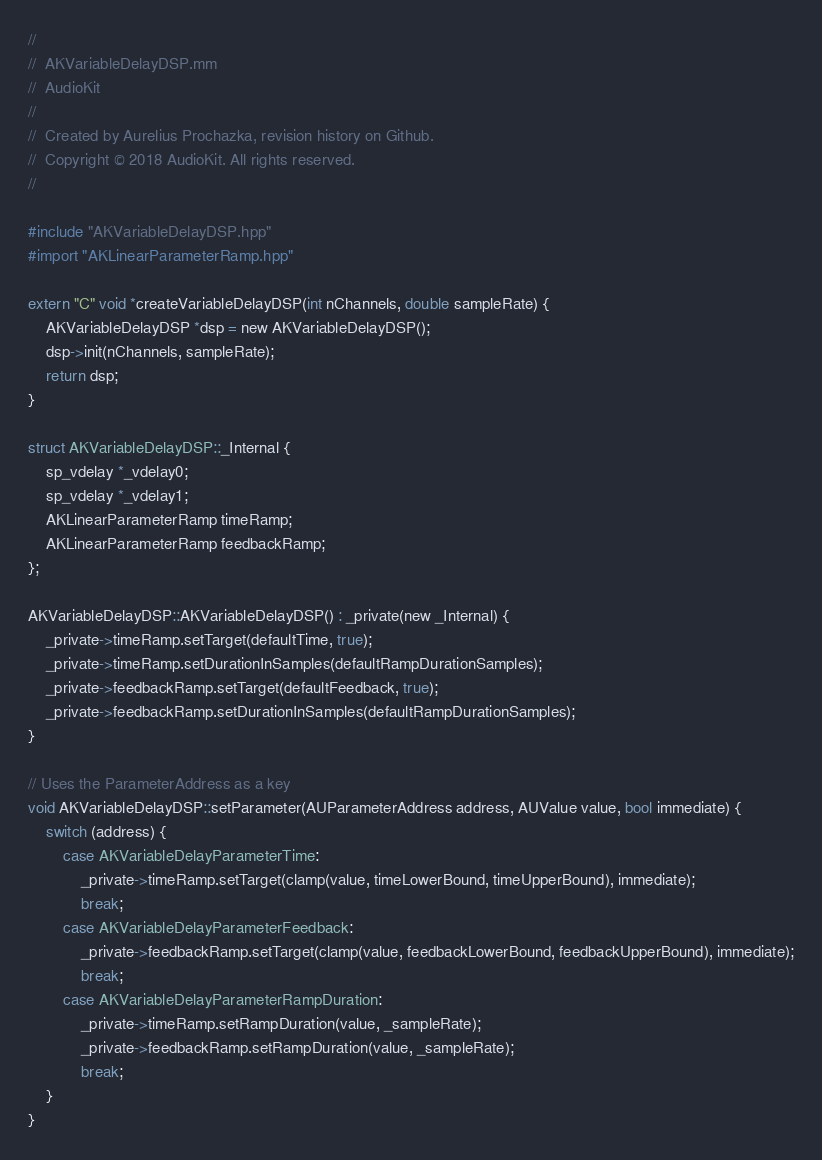Convert code to text. <code><loc_0><loc_0><loc_500><loc_500><_ObjectiveC_>//
//  AKVariableDelayDSP.mm
//  AudioKit
//
//  Created by Aurelius Prochazka, revision history on Github.
//  Copyright © 2018 AudioKit. All rights reserved.
//

#include "AKVariableDelayDSP.hpp"
#import "AKLinearParameterRamp.hpp"

extern "C" void *createVariableDelayDSP(int nChannels, double sampleRate) {
    AKVariableDelayDSP *dsp = new AKVariableDelayDSP();
    dsp->init(nChannels, sampleRate);
    return dsp;
}

struct AKVariableDelayDSP::_Internal {
    sp_vdelay *_vdelay0;
    sp_vdelay *_vdelay1;
    AKLinearParameterRamp timeRamp;
    AKLinearParameterRamp feedbackRamp;
};

AKVariableDelayDSP::AKVariableDelayDSP() : _private(new _Internal) {
    _private->timeRamp.setTarget(defaultTime, true);
    _private->timeRamp.setDurationInSamples(defaultRampDurationSamples);
    _private->feedbackRamp.setTarget(defaultFeedback, true);
    _private->feedbackRamp.setDurationInSamples(defaultRampDurationSamples);
}

// Uses the ParameterAddress as a key
void AKVariableDelayDSP::setParameter(AUParameterAddress address, AUValue value, bool immediate) {
    switch (address) {
        case AKVariableDelayParameterTime:
            _private->timeRamp.setTarget(clamp(value, timeLowerBound, timeUpperBound), immediate);
            break;
        case AKVariableDelayParameterFeedback:
            _private->feedbackRamp.setTarget(clamp(value, feedbackLowerBound, feedbackUpperBound), immediate);
            break;
        case AKVariableDelayParameterRampDuration:
            _private->timeRamp.setRampDuration(value, _sampleRate);
            _private->feedbackRamp.setRampDuration(value, _sampleRate);
            break;
    }
}
</code> 